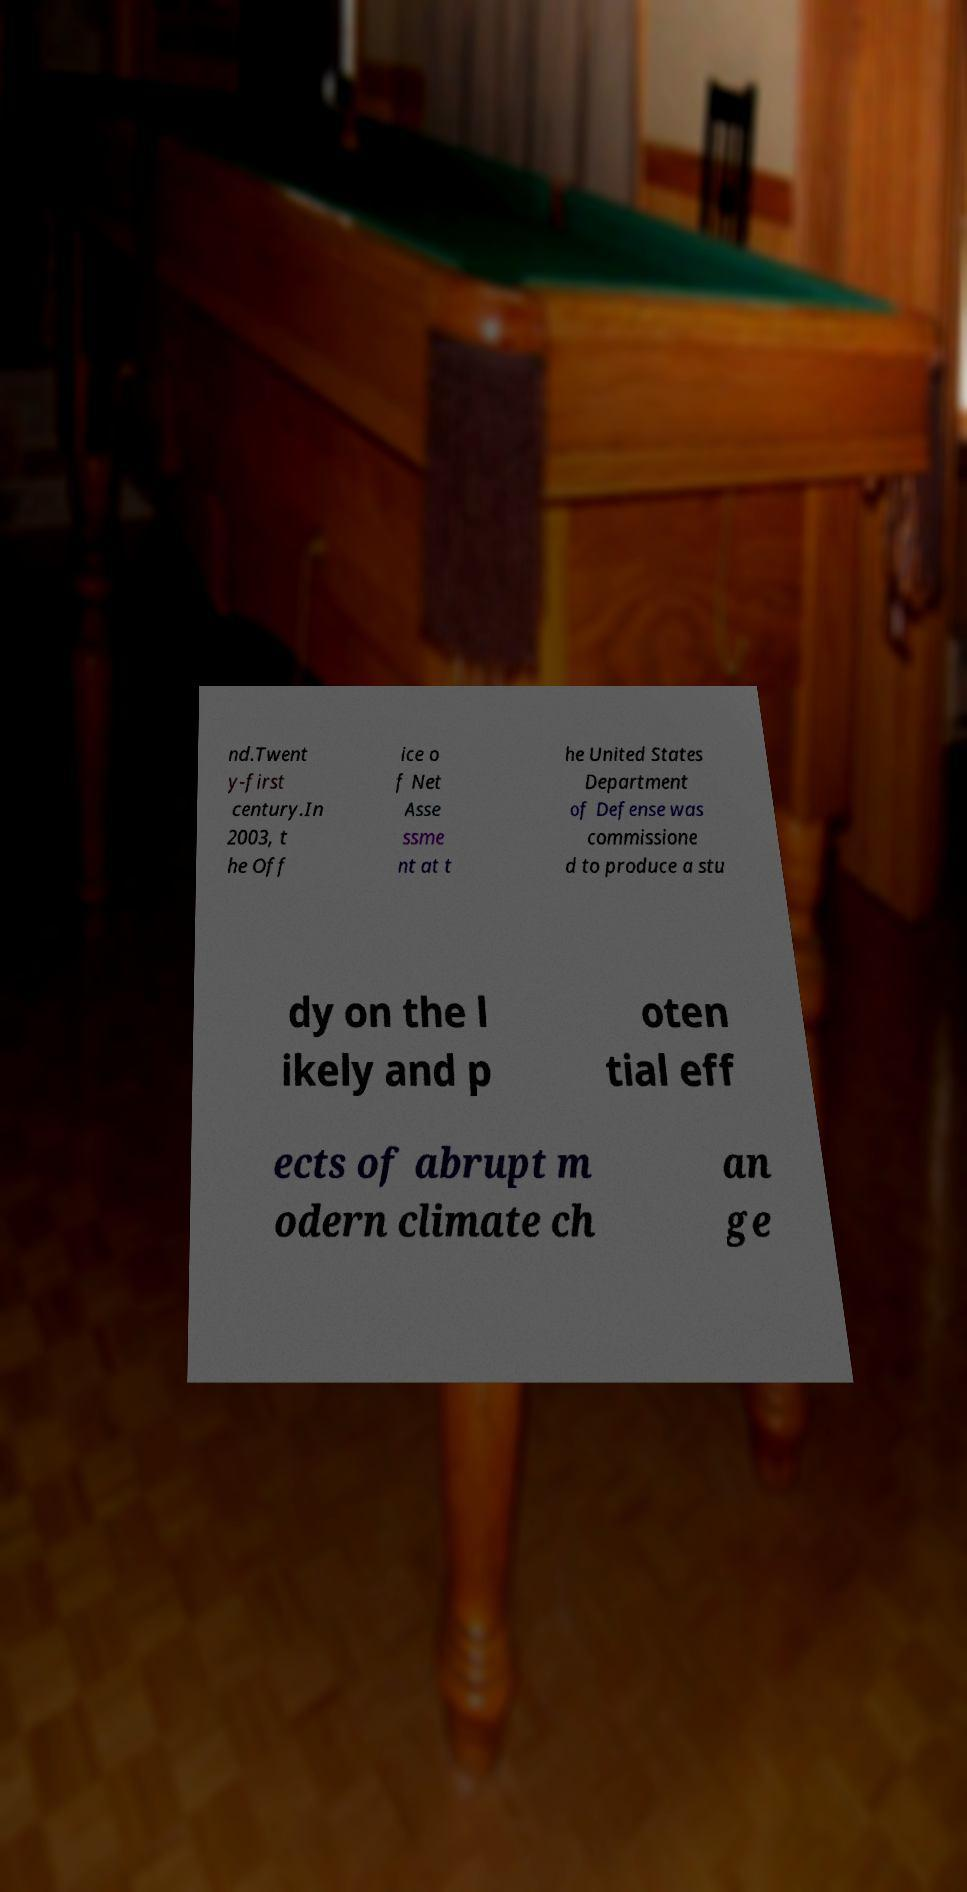Could you extract and type out the text from this image? nd.Twent y-first century.In 2003, t he Off ice o f Net Asse ssme nt at t he United States Department of Defense was commissione d to produce a stu dy on the l ikely and p oten tial eff ects of abrupt m odern climate ch an ge 